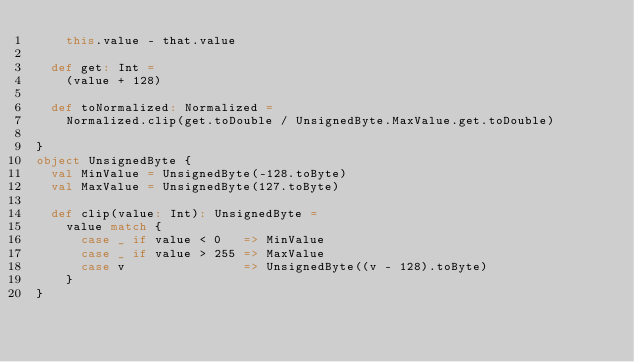Convert code to text. <code><loc_0><loc_0><loc_500><loc_500><_Scala_>    this.value - that.value

  def get: Int =
    (value + 128)

  def toNormalized: Normalized =
    Normalized.clip(get.toDouble / UnsignedByte.MaxValue.get.toDouble)

}
object UnsignedByte {
  val MinValue = UnsignedByte(-128.toByte)
  val MaxValue = UnsignedByte(127.toByte)

  def clip(value: Int): UnsignedByte =
    value match {
      case _ if value < 0   => MinValue
      case _ if value > 255 => MaxValue
      case v                => UnsignedByte((v - 128).toByte)
    }
}
</code> 